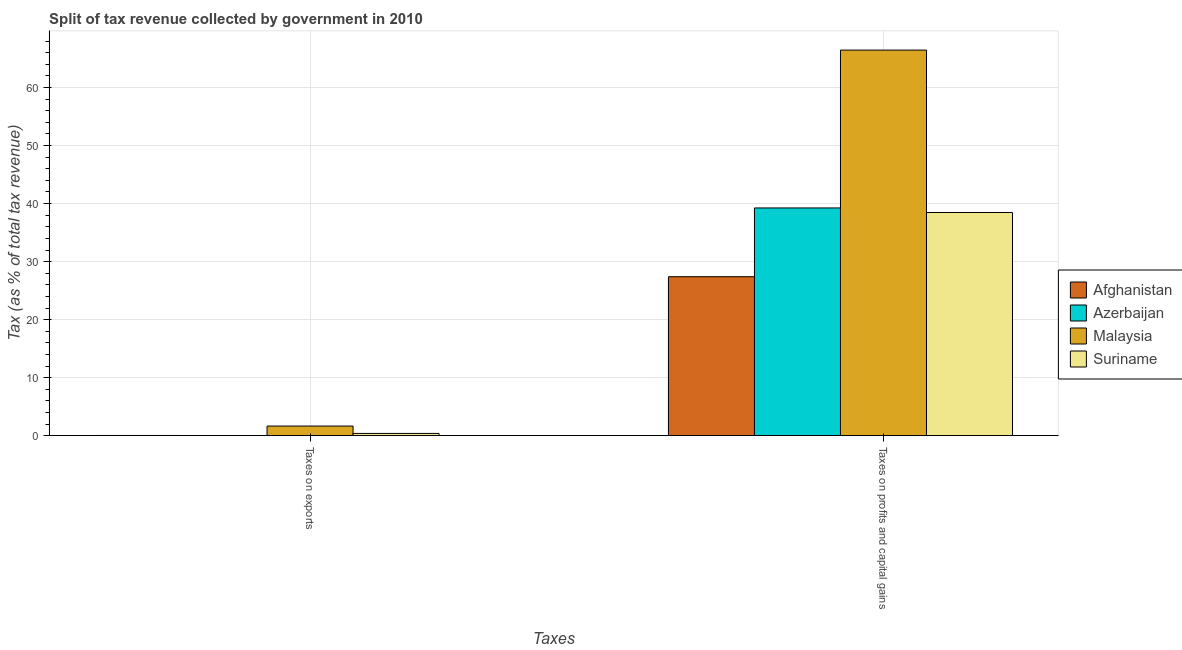Are the number of bars per tick equal to the number of legend labels?
Provide a short and direct response. Yes. Are the number of bars on each tick of the X-axis equal?
Your answer should be very brief. Yes. What is the label of the 2nd group of bars from the left?
Provide a short and direct response. Taxes on profits and capital gains. What is the percentage of revenue obtained from taxes on exports in Malaysia?
Ensure brevity in your answer.  1.65. Across all countries, what is the maximum percentage of revenue obtained from taxes on exports?
Ensure brevity in your answer.  1.65. Across all countries, what is the minimum percentage of revenue obtained from taxes on profits and capital gains?
Your response must be concise. 27.4. In which country was the percentage of revenue obtained from taxes on exports maximum?
Your answer should be very brief. Malaysia. In which country was the percentage of revenue obtained from taxes on profits and capital gains minimum?
Provide a short and direct response. Afghanistan. What is the total percentage of revenue obtained from taxes on profits and capital gains in the graph?
Your answer should be very brief. 171.58. What is the difference between the percentage of revenue obtained from taxes on exports in Afghanistan and that in Azerbaijan?
Make the answer very short. 0.03. What is the difference between the percentage of revenue obtained from taxes on exports in Azerbaijan and the percentage of revenue obtained from taxes on profits and capital gains in Afghanistan?
Your answer should be very brief. -27.39. What is the average percentage of revenue obtained from taxes on exports per country?
Your response must be concise. 0.52. What is the difference between the percentage of revenue obtained from taxes on profits and capital gains and percentage of revenue obtained from taxes on exports in Azerbaijan?
Provide a succinct answer. 39.25. What is the ratio of the percentage of revenue obtained from taxes on exports in Suriname to that in Afghanistan?
Ensure brevity in your answer.  12.94. What does the 3rd bar from the left in Taxes on profits and capital gains represents?
Your answer should be very brief. Malaysia. What does the 3rd bar from the right in Taxes on profits and capital gains represents?
Provide a succinct answer. Azerbaijan. Are all the bars in the graph horizontal?
Provide a short and direct response. No. How many countries are there in the graph?
Your response must be concise. 4. Does the graph contain grids?
Your response must be concise. Yes. Where does the legend appear in the graph?
Give a very brief answer. Center right. How many legend labels are there?
Keep it short and to the point. 4. How are the legend labels stacked?
Provide a short and direct response. Vertical. What is the title of the graph?
Ensure brevity in your answer.  Split of tax revenue collected by government in 2010. Does "Sub-Saharan Africa (developing only)" appear as one of the legend labels in the graph?
Give a very brief answer. No. What is the label or title of the X-axis?
Keep it short and to the point. Taxes. What is the label or title of the Y-axis?
Make the answer very short. Tax (as % of total tax revenue). What is the Tax (as % of total tax revenue) in Afghanistan in Taxes on exports?
Provide a succinct answer. 0.03. What is the Tax (as % of total tax revenue) in Azerbaijan in Taxes on exports?
Your answer should be very brief. 0. What is the Tax (as % of total tax revenue) of Malaysia in Taxes on exports?
Offer a terse response. 1.65. What is the Tax (as % of total tax revenue) in Suriname in Taxes on exports?
Your answer should be compact. 0.38. What is the Tax (as % of total tax revenue) of Afghanistan in Taxes on profits and capital gains?
Make the answer very short. 27.4. What is the Tax (as % of total tax revenue) in Azerbaijan in Taxes on profits and capital gains?
Provide a succinct answer. 39.25. What is the Tax (as % of total tax revenue) of Malaysia in Taxes on profits and capital gains?
Offer a very short reply. 66.46. What is the Tax (as % of total tax revenue) in Suriname in Taxes on profits and capital gains?
Keep it short and to the point. 38.47. Across all Taxes, what is the maximum Tax (as % of total tax revenue) of Afghanistan?
Provide a short and direct response. 27.4. Across all Taxes, what is the maximum Tax (as % of total tax revenue) in Azerbaijan?
Ensure brevity in your answer.  39.25. Across all Taxes, what is the maximum Tax (as % of total tax revenue) of Malaysia?
Your response must be concise. 66.46. Across all Taxes, what is the maximum Tax (as % of total tax revenue) of Suriname?
Your answer should be very brief. 38.47. Across all Taxes, what is the minimum Tax (as % of total tax revenue) in Afghanistan?
Provide a short and direct response. 0.03. Across all Taxes, what is the minimum Tax (as % of total tax revenue) in Azerbaijan?
Provide a short and direct response. 0. Across all Taxes, what is the minimum Tax (as % of total tax revenue) of Malaysia?
Provide a short and direct response. 1.65. Across all Taxes, what is the minimum Tax (as % of total tax revenue) in Suriname?
Ensure brevity in your answer.  0.38. What is the total Tax (as % of total tax revenue) in Afghanistan in the graph?
Offer a terse response. 27.43. What is the total Tax (as % of total tax revenue) of Azerbaijan in the graph?
Offer a very short reply. 39.26. What is the total Tax (as % of total tax revenue) in Malaysia in the graph?
Ensure brevity in your answer.  68.11. What is the total Tax (as % of total tax revenue) in Suriname in the graph?
Provide a succinct answer. 38.85. What is the difference between the Tax (as % of total tax revenue) in Afghanistan in Taxes on exports and that in Taxes on profits and capital gains?
Offer a very short reply. -27.37. What is the difference between the Tax (as % of total tax revenue) of Azerbaijan in Taxes on exports and that in Taxes on profits and capital gains?
Provide a succinct answer. -39.25. What is the difference between the Tax (as % of total tax revenue) in Malaysia in Taxes on exports and that in Taxes on profits and capital gains?
Make the answer very short. -64.81. What is the difference between the Tax (as % of total tax revenue) in Suriname in Taxes on exports and that in Taxes on profits and capital gains?
Your answer should be very brief. -38.09. What is the difference between the Tax (as % of total tax revenue) of Afghanistan in Taxes on exports and the Tax (as % of total tax revenue) of Azerbaijan in Taxes on profits and capital gains?
Offer a terse response. -39.22. What is the difference between the Tax (as % of total tax revenue) in Afghanistan in Taxes on exports and the Tax (as % of total tax revenue) in Malaysia in Taxes on profits and capital gains?
Make the answer very short. -66.43. What is the difference between the Tax (as % of total tax revenue) in Afghanistan in Taxes on exports and the Tax (as % of total tax revenue) in Suriname in Taxes on profits and capital gains?
Offer a very short reply. -38.44. What is the difference between the Tax (as % of total tax revenue) in Azerbaijan in Taxes on exports and the Tax (as % of total tax revenue) in Malaysia in Taxes on profits and capital gains?
Make the answer very short. -66.46. What is the difference between the Tax (as % of total tax revenue) of Azerbaijan in Taxes on exports and the Tax (as % of total tax revenue) of Suriname in Taxes on profits and capital gains?
Provide a short and direct response. -38.46. What is the difference between the Tax (as % of total tax revenue) of Malaysia in Taxes on exports and the Tax (as % of total tax revenue) of Suriname in Taxes on profits and capital gains?
Offer a terse response. -36.82. What is the average Tax (as % of total tax revenue) in Afghanistan per Taxes?
Your answer should be compact. 13.71. What is the average Tax (as % of total tax revenue) in Azerbaijan per Taxes?
Your response must be concise. 19.63. What is the average Tax (as % of total tax revenue) in Malaysia per Taxes?
Keep it short and to the point. 34.06. What is the average Tax (as % of total tax revenue) in Suriname per Taxes?
Your answer should be compact. 19.42. What is the difference between the Tax (as % of total tax revenue) of Afghanistan and Tax (as % of total tax revenue) of Azerbaijan in Taxes on exports?
Your answer should be very brief. 0.03. What is the difference between the Tax (as % of total tax revenue) in Afghanistan and Tax (as % of total tax revenue) in Malaysia in Taxes on exports?
Ensure brevity in your answer.  -1.62. What is the difference between the Tax (as % of total tax revenue) of Afghanistan and Tax (as % of total tax revenue) of Suriname in Taxes on exports?
Ensure brevity in your answer.  -0.35. What is the difference between the Tax (as % of total tax revenue) of Azerbaijan and Tax (as % of total tax revenue) of Malaysia in Taxes on exports?
Make the answer very short. -1.65. What is the difference between the Tax (as % of total tax revenue) in Azerbaijan and Tax (as % of total tax revenue) in Suriname in Taxes on exports?
Make the answer very short. -0.38. What is the difference between the Tax (as % of total tax revenue) of Malaysia and Tax (as % of total tax revenue) of Suriname in Taxes on exports?
Offer a very short reply. 1.27. What is the difference between the Tax (as % of total tax revenue) in Afghanistan and Tax (as % of total tax revenue) in Azerbaijan in Taxes on profits and capital gains?
Provide a short and direct response. -11.85. What is the difference between the Tax (as % of total tax revenue) in Afghanistan and Tax (as % of total tax revenue) in Malaysia in Taxes on profits and capital gains?
Offer a terse response. -39.06. What is the difference between the Tax (as % of total tax revenue) of Afghanistan and Tax (as % of total tax revenue) of Suriname in Taxes on profits and capital gains?
Your answer should be very brief. -11.07. What is the difference between the Tax (as % of total tax revenue) of Azerbaijan and Tax (as % of total tax revenue) of Malaysia in Taxes on profits and capital gains?
Offer a very short reply. -27.21. What is the difference between the Tax (as % of total tax revenue) in Azerbaijan and Tax (as % of total tax revenue) in Suriname in Taxes on profits and capital gains?
Give a very brief answer. 0.78. What is the difference between the Tax (as % of total tax revenue) of Malaysia and Tax (as % of total tax revenue) of Suriname in Taxes on profits and capital gains?
Provide a succinct answer. 27.99. What is the ratio of the Tax (as % of total tax revenue) of Afghanistan in Taxes on exports to that in Taxes on profits and capital gains?
Your response must be concise. 0. What is the ratio of the Tax (as % of total tax revenue) in Malaysia in Taxes on exports to that in Taxes on profits and capital gains?
Offer a terse response. 0.02. What is the ratio of the Tax (as % of total tax revenue) of Suriname in Taxes on exports to that in Taxes on profits and capital gains?
Offer a terse response. 0.01. What is the difference between the highest and the second highest Tax (as % of total tax revenue) of Afghanistan?
Offer a terse response. 27.37. What is the difference between the highest and the second highest Tax (as % of total tax revenue) in Azerbaijan?
Make the answer very short. 39.25. What is the difference between the highest and the second highest Tax (as % of total tax revenue) of Malaysia?
Give a very brief answer. 64.81. What is the difference between the highest and the second highest Tax (as % of total tax revenue) of Suriname?
Provide a short and direct response. 38.09. What is the difference between the highest and the lowest Tax (as % of total tax revenue) of Afghanistan?
Provide a succinct answer. 27.37. What is the difference between the highest and the lowest Tax (as % of total tax revenue) of Azerbaijan?
Ensure brevity in your answer.  39.25. What is the difference between the highest and the lowest Tax (as % of total tax revenue) of Malaysia?
Your answer should be compact. 64.81. What is the difference between the highest and the lowest Tax (as % of total tax revenue) of Suriname?
Keep it short and to the point. 38.09. 